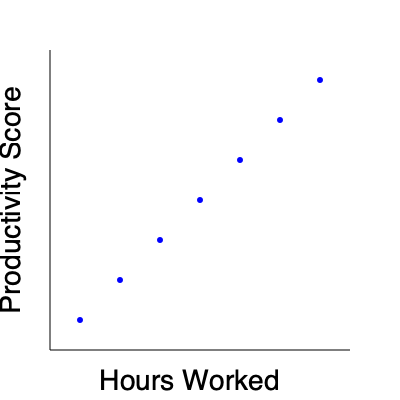As a data analyst, you're examining the relationship between hours worked and productivity scores in your firm. Based on the scatter plot, what type of correlation exists between these variables, and what does this suggest about the impact of working hours on productivity? To interpret the scatter plot and determine the correlation between hours worked and productivity scores, follow these steps:

1. Observe the overall trend:
   The points in the scatter plot form a clear pattern from the bottom-left to the top-right of the graph.

2. Identify the direction of the relationship:
   As the hours worked (x-axis) increase, the productivity scores (y-axis) also increase. This indicates a positive relationship.

3. Assess the strength of the relationship:
   The points fall close to an imaginary straight line, suggesting a strong relationship between the variables.

4. Determine the type of correlation:
   Based on the strong, positive relationship observed, this scatter plot demonstrates a strong positive correlation between hours worked and productivity scores.

5. Interpret the results:
   This correlation suggests that as employees work more hours, their productivity scores tend to increase. However, it's important to note that correlation does not imply causation. Other factors may influence this relationship, and working longer hours may not always lead to increased productivity in all situations.

6. Consider implications:
   While the data shows a positive relationship, it's crucial to consider factors such as employee well-being, work-life balance, and potential diminishing returns on productivity for extremely long work hours.
Answer: Strong positive correlation; suggests increased working hours are associated with higher productivity scores. 